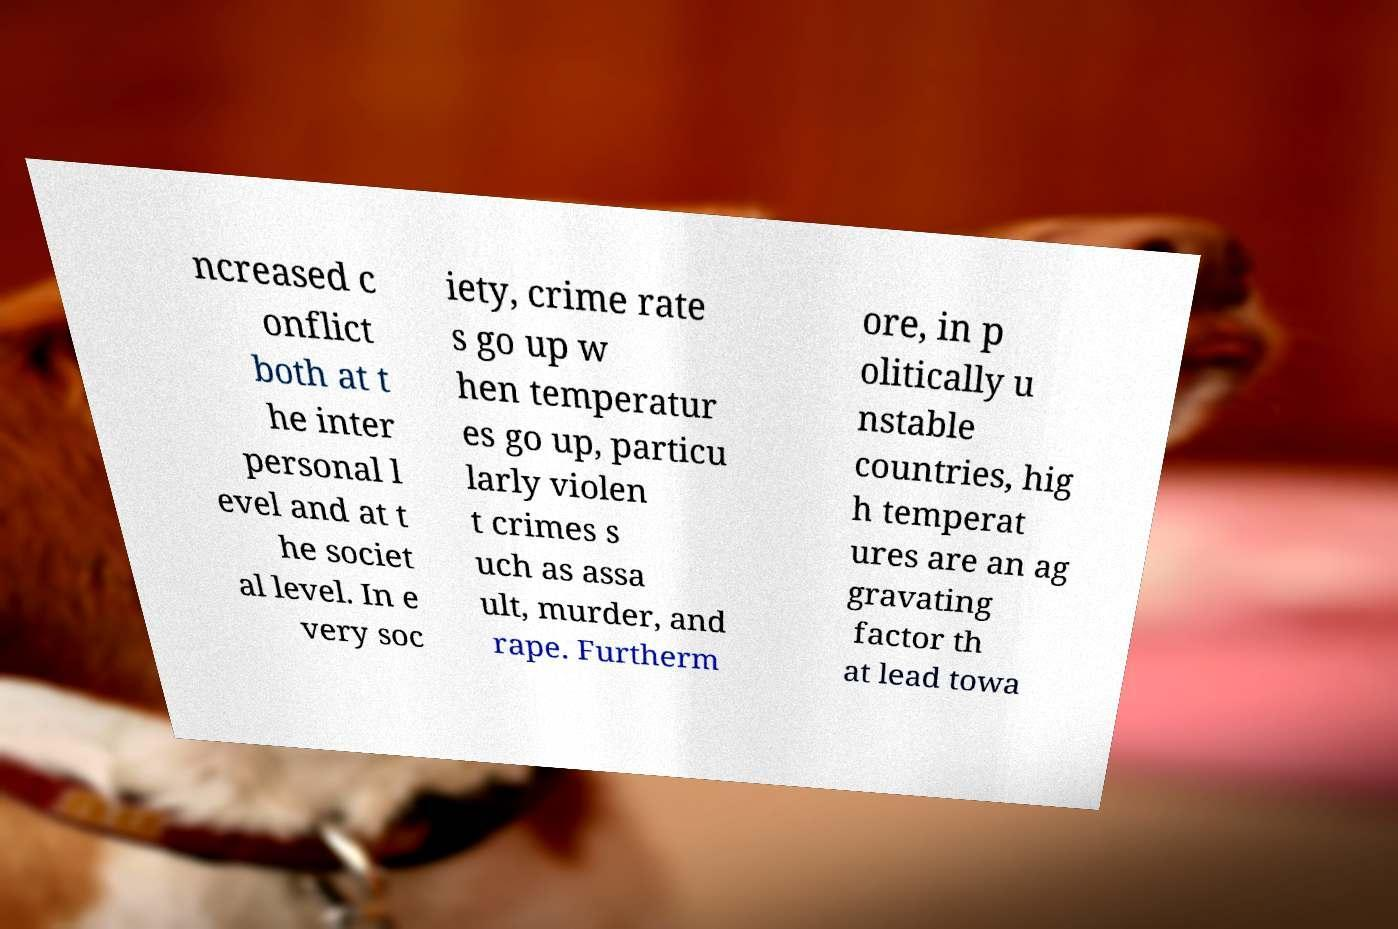For documentation purposes, I need the text within this image transcribed. Could you provide that? ncreased c onflict both at t he inter personal l evel and at t he societ al level. In e very soc iety, crime rate s go up w hen temperatur es go up, particu larly violen t crimes s uch as assa ult, murder, and rape. Furtherm ore, in p olitically u nstable countries, hig h temperat ures are an ag gravating factor th at lead towa 